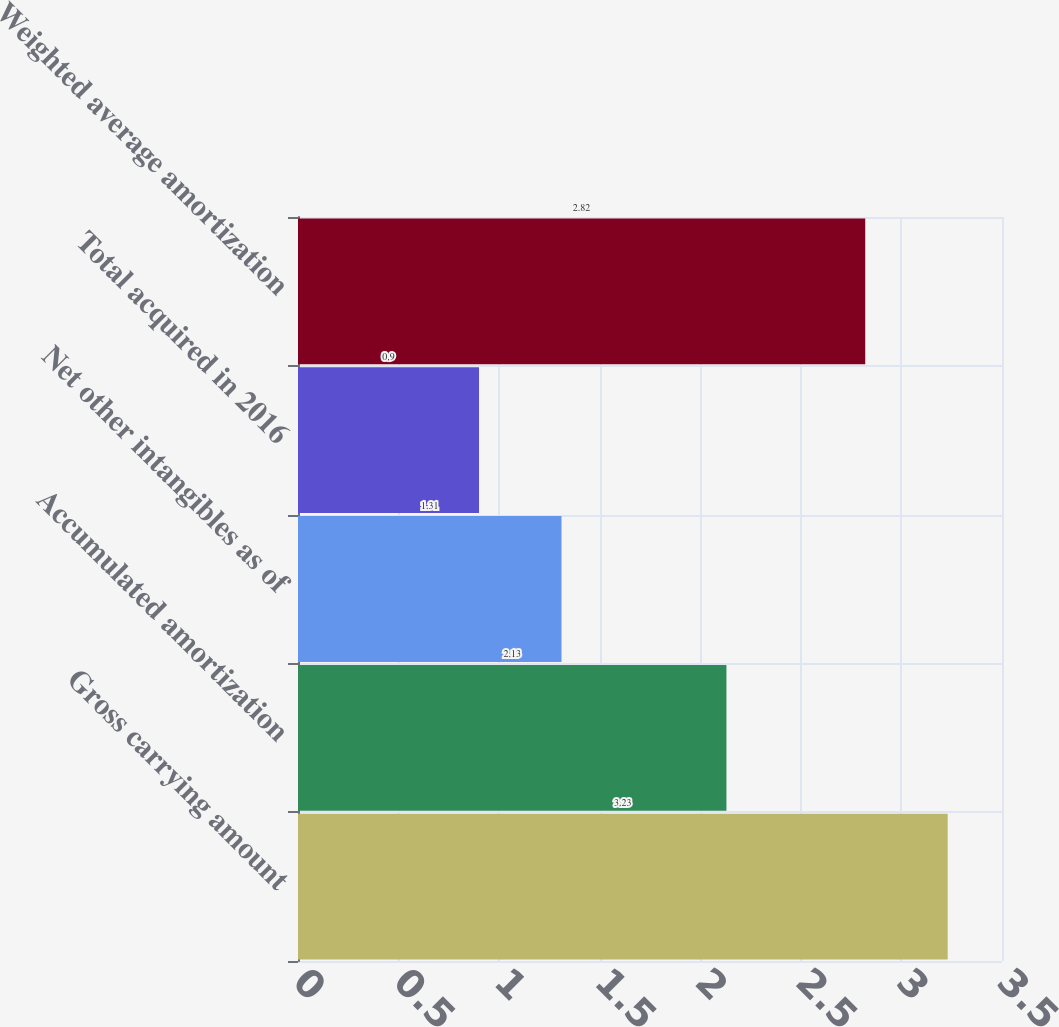<chart> <loc_0><loc_0><loc_500><loc_500><bar_chart><fcel>Gross carrying amount<fcel>Accumulated amortization<fcel>Net other intangibles as of<fcel>Total acquired in 2016<fcel>Weighted average amortization<nl><fcel>3.23<fcel>2.13<fcel>1.31<fcel>0.9<fcel>2.82<nl></chart> 